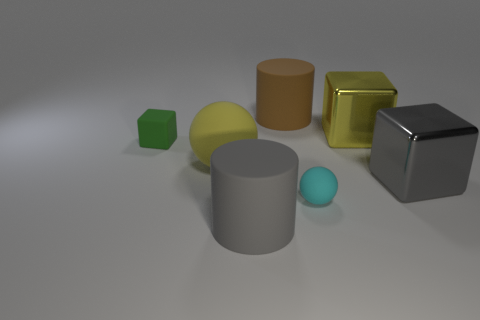Add 2 rubber blocks. How many objects exist? 9 Subtract all big yellow shiny cubes. How many cubes are left? 2 Subtract all blocks. How many objects are left? 4 Subtract 1 spheres. How many spheres are left? 1 Add 6 big yellow metal objects. How many big yellow metal objects are left? 7 Add 5 tiny cyan metallic cylinders. How many tiny cyan metallic cylinders exist? 5 Subtract all brown cylinders. How many cylinders are left? 1 Subtract 0 brown blocks. How many objects are left? 7 Subtract all blue balls. Subtract all cyan cubes. How many balls are left? 2 Subtract all small green rubber cubes. Subtract all big yellow rubber things. How many objects are left? 5 